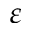<formula> <loc_0><loc_0><loc_500><loc_500>\varepsilon</formula> 